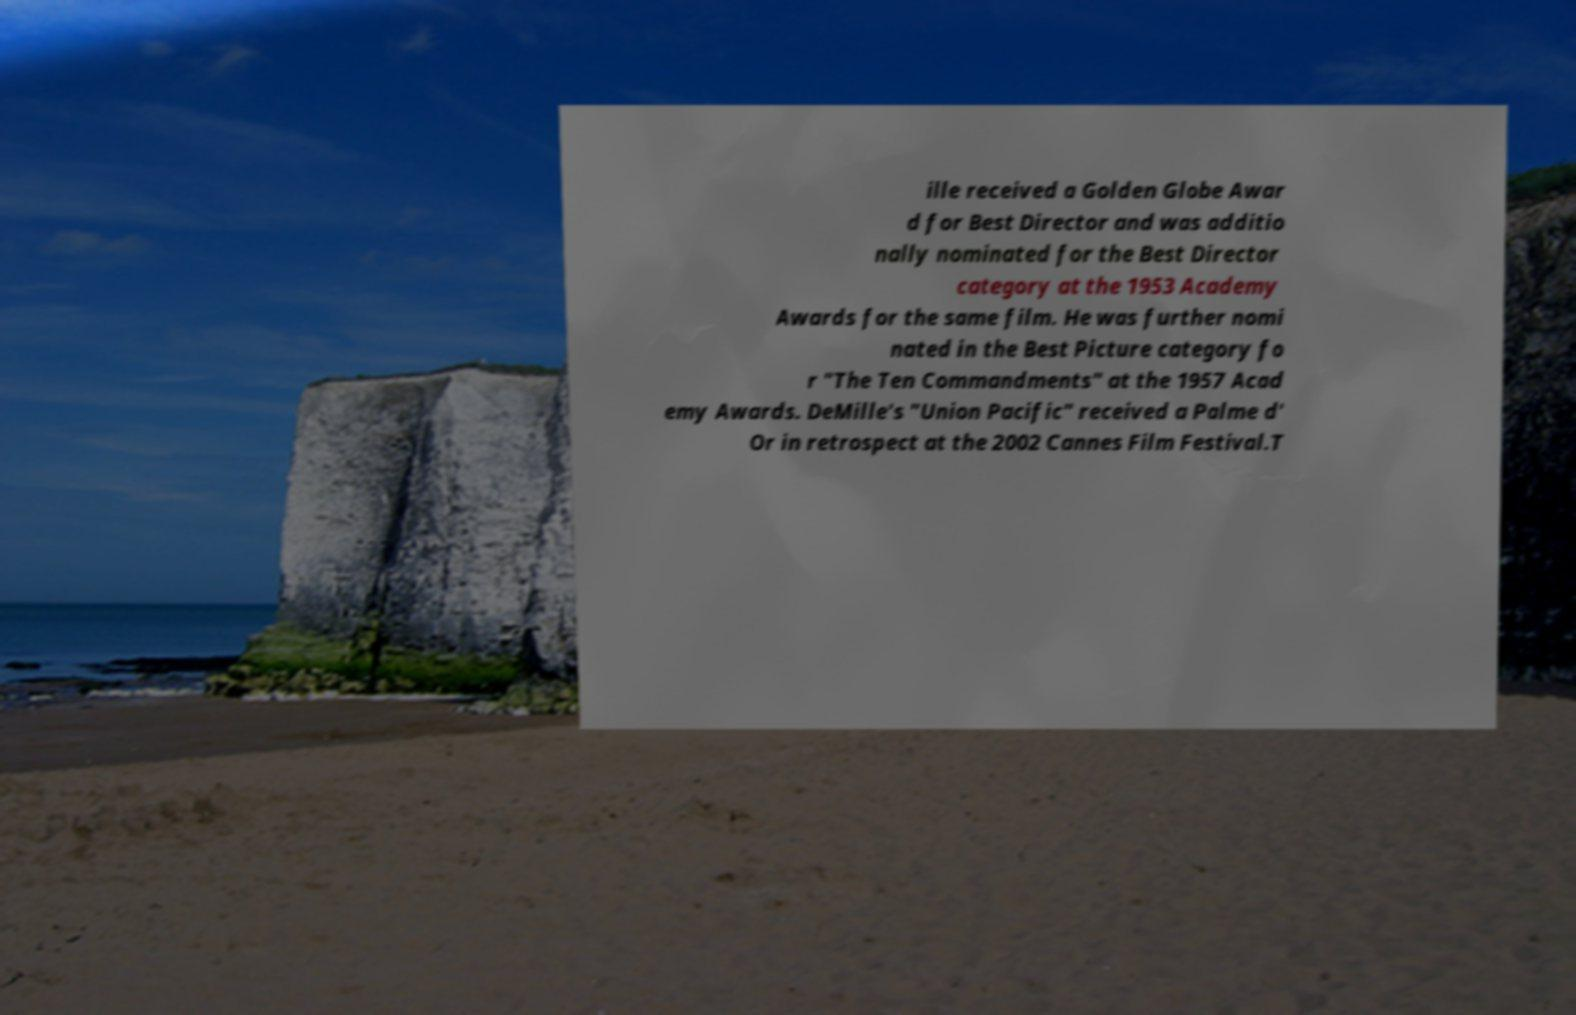Can you read and provide the text displayed in the image?This photo seems to have some interesting text. Can you extract and type it out for me? ille received a Golden Globe Awar d for Best Director and was additio nally nominated for the Best Director category at the 1953 Academy Awards for the same film. He was further nomi nated in the Best Picture category fo r "The Ten Commandments" at the 1957 Acad emy Awards. DeMille's "Union Pacific" received a Palme d' Or in retrospect at the 2002 Cannes Film Festival.T 